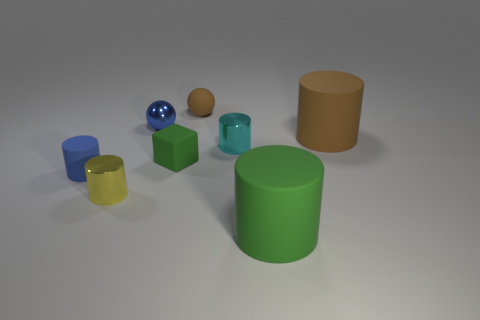Is the shape of the tiny blue rubber thing the same as the green object that is in front of the small yellow metallic thing?
Your answer should be compact. Yes. Are there any tiny metallic balls on the right side of the tiny blue metallic ball?
Provide a succinct answer. No. What number of yellow objects have the same shape as the small brown rubber object?
Your answer should be very brief. 0. Is the material of the green block the same as the sphere that is to the left of the rubber ball?
Provide a succinct answer. No. How many big red rubber objects are there?
Give a very brief answer. 0. There is a metal object that is right of the tiny block; what is its size?
Offer a terse response. Small. How many cyan metal cylinders have the same size as the green matte cylinder?
Provide a succinct answer. 0. There is a thing that is both in front of the blue matte thing and left of the tiny metal sphere; what material is it made of?
Offer a very short reply. Metal. What material is the yellow thing that is the same size as the blue cylinder?
Offer a very short reply. Metal. How big is the rubber object right of the large rubber thing in front of the shiny cylinder behind the tiny yellow thing?
Your response must be concise. Large. 